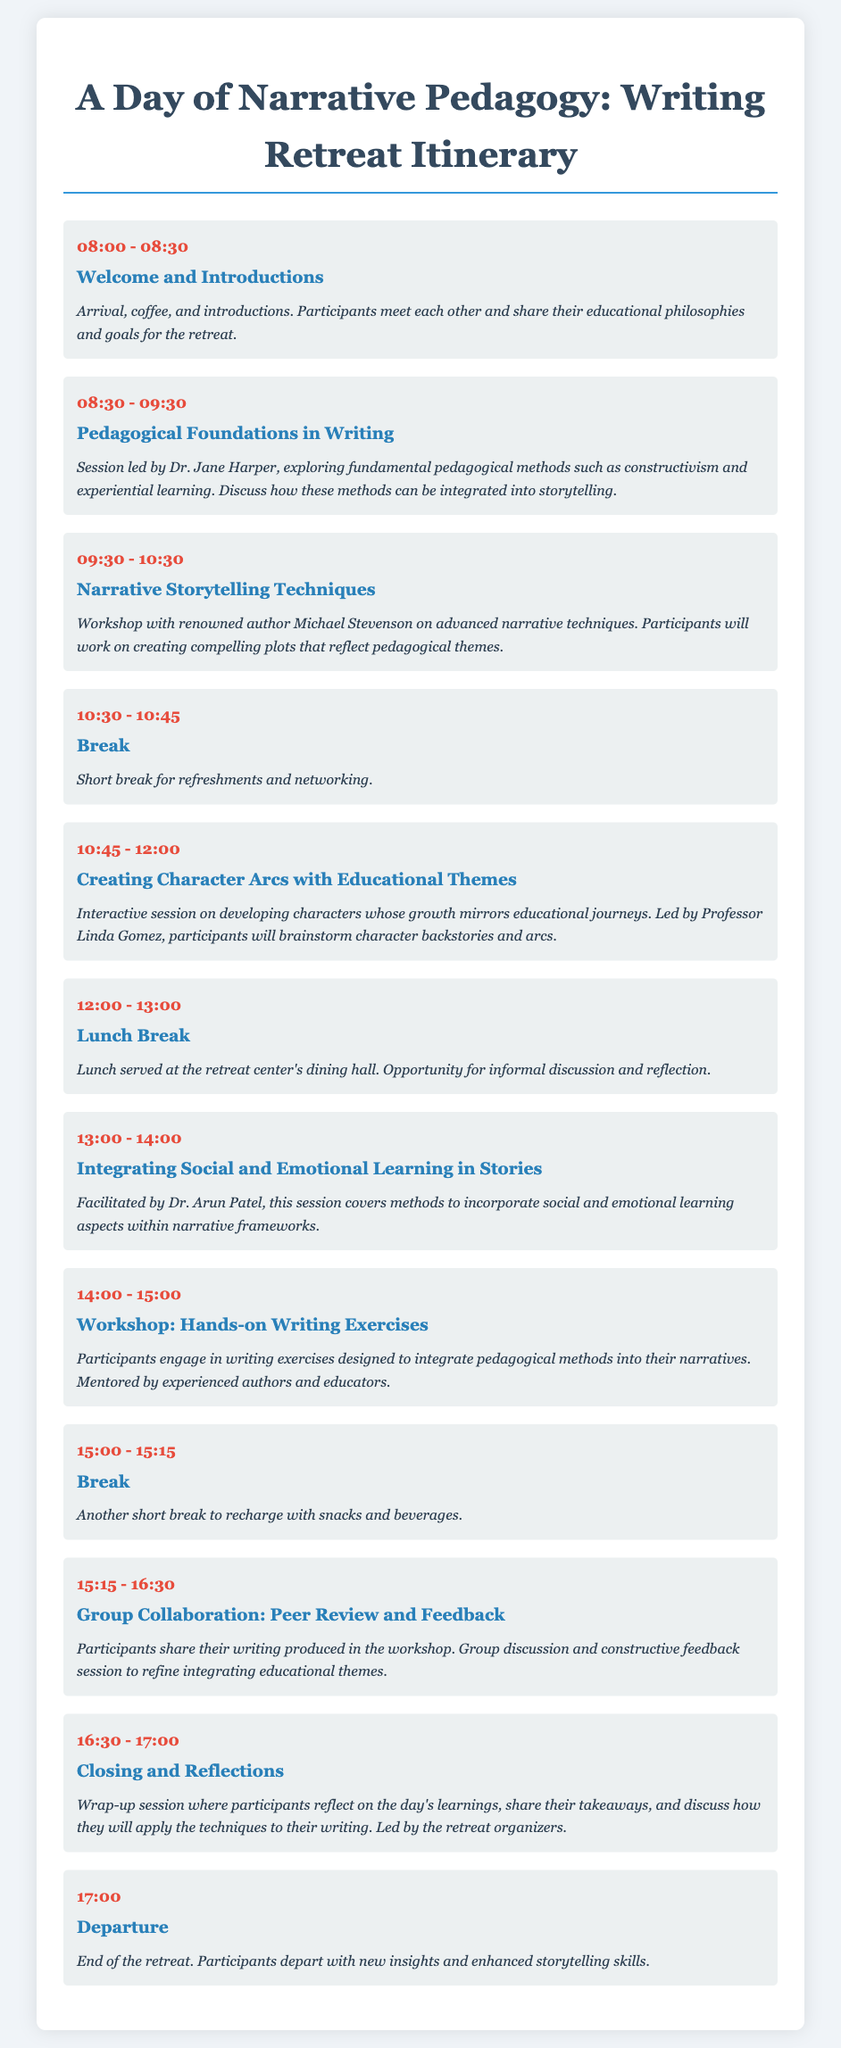What time does the retreat start? The retreat starts with the Welcome and Introductions session at 8:00 AM.
Answer: 08:00 Who is leading the session on Pedagogical Foundations in Writing? The session on Pedagogical Foundations in Writing is led by Dr. Jane Harper.
Answer: Dr. Jane Harper What is the duration of the lunch break? The lunch break is scheduled for one hour from 12:00 PM to 1:00 PM.
Answer: 1 hour Which session focuses on character development? The session that focuses on character development is titled "Creating Character Arcs with Educational Themes."
Answer: Creating Character Arcs with Educational Themes What time is the closing session scheduled? The closing session is scheduled for 4:30 PM to 5:00 PM.
Answer: 16:30 - 17:00 How many writing exercises are presented in the workshop? The workshop includes hands-on writing exercises designed to integrate pedagogical methods into narratives, but the specific number is not stated.
Answer: Not specified What is the main theme of the retreat? The main theme of the retreat is narrative pedagogy, focusing on the integration of pedagogical methods in storytelling.
Answer: Narrative Pedagogy What is the last session of the day? The last session of the day is the "Closing and Reflections."
Answer: Closing and Reflections 